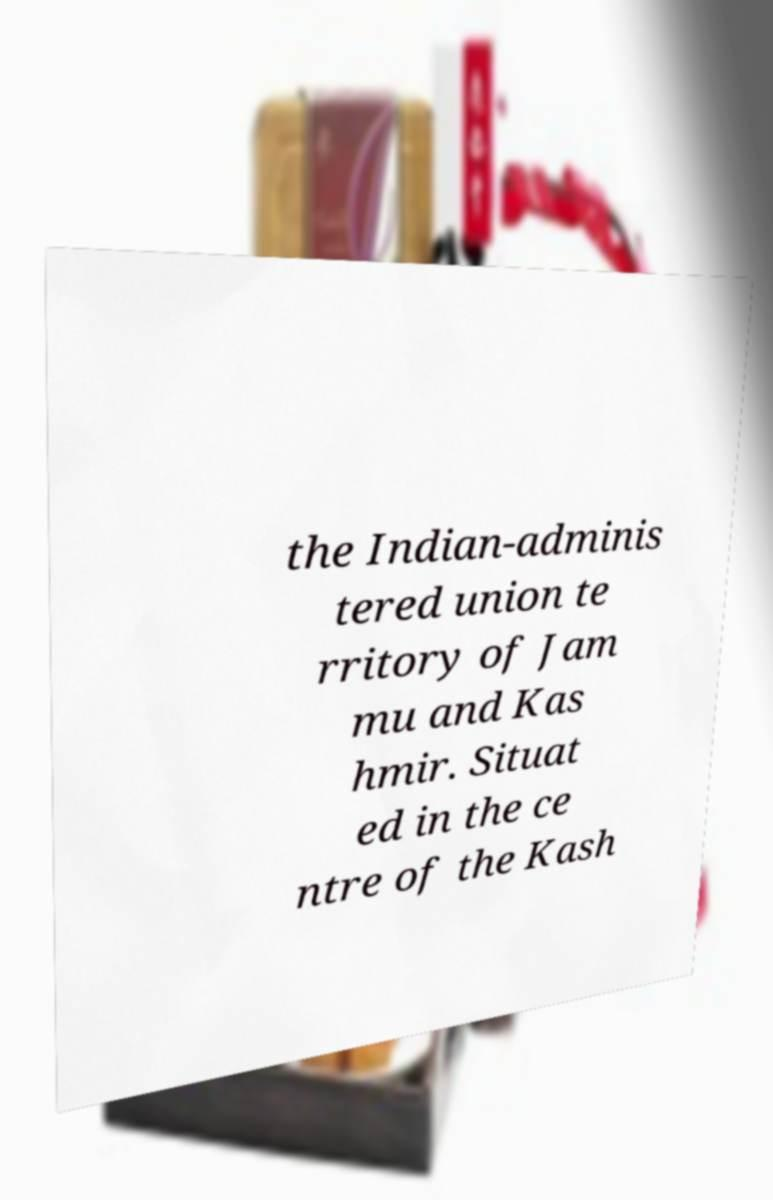What messages or text are displayed in this image? I need them in a readable, typed format. the Indian-adminis tered union te rritory of Jam mu and Kas hmir. Situat ed in the ce ntre of the Kash 